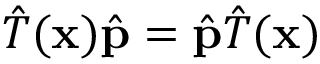<formula> <loc_0><loc_0><loc_500><loc_500>{ \hat { T } } ( x ) { \hat { p } } = { \hat { p } } { \hat { T } } ( x )</formula> 